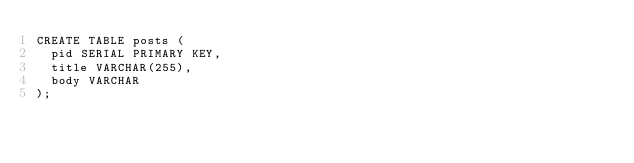<code> <loc_0><loc_0><loc_500><loc_500><_SQL_>CREATE TABLE posts (
  pid SERIAL PRIMARY KEY,
  title VARCHAR(255),
  body VARCHAR
);
</code> 